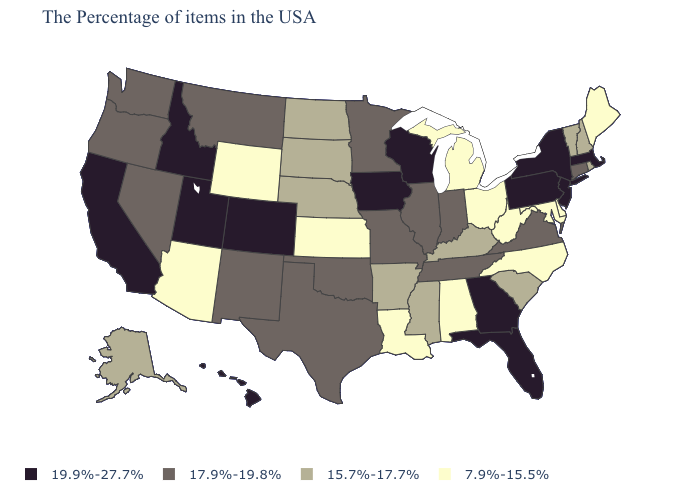Does Oklahoma have the lowest value in the South?
Short answer required. No. Name the states that have a value in the range 17.9%-19.8%?
Quick response, please. Connecticut, Virginia, Indiana, Tennessee, Illinois, Missouri, Minnesota, Oklahoma, Texas, New Mexico, Montana, Nevada, Washington, Oregon. Which states have the lowest value in the West?
Answer briefly. Wyoming, Arizona. Which states have the highest value in the USA?
Be succinct. Massachusetts, New York, New Jersey, Pennsylvania, Florida, Georgia, Wisconsin, Iowa, Colorado, Utah, Idaho, California, Hawaii. Does the first symbol in the legend represent the smallest category?
Concise answer only. No. Name the states that have a value in the range 7.9%-15.5%?
Write a very short answer. Maine, Delaware, Maryland, North Carolina, West Virginia, Ohio, Michigan, Alabama, Louisiana, Kansas, Wyoming, Arizona. Does Wyoming have the lowest value in the West?
Concise answer only. Yes. Name the states that have a value in the range 7.9%-15.5%?
Short answer required. Maine, Delaware, Maryland, North Carolina, West Virginia, Ohio, Michigan, Alabama, Louisiana, Kansas, Wyoming, Arizona. What is the lowest value in states that border North Carolina?
Give a very brief answer. 15.7%-17.7%. What is the value of New Mexico?
Quick response, please. 17.9%-19.8%. Does Maine have the lowest value in the Northeast?
Write a very short answer. Yes. Which states hav the highest value in the MidWest?
Answer briefly. Wisconsin, Iowa. Does Washington have a lower value than New Mexico?
Give a very brief answer. No. What is the value of New Jersey?
Quick response, please. 19.9%-27.7%. Does Hawaii have the highest value in the West?
Write a very short answer. Yes. 